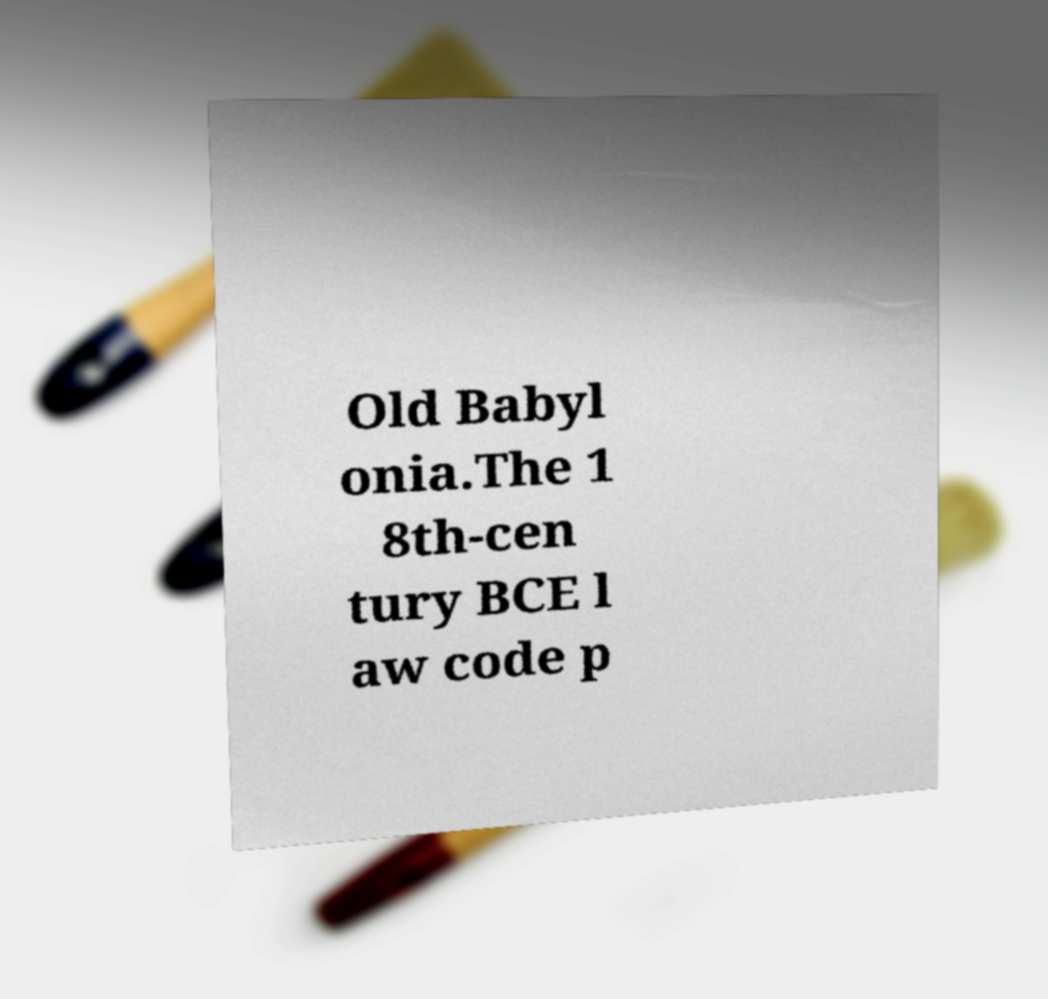For documentation purposes, I need the text within this image transcribed. Could you provide that? Old Babyl onia.The 1 8th-cen tury BCE l aw code p 